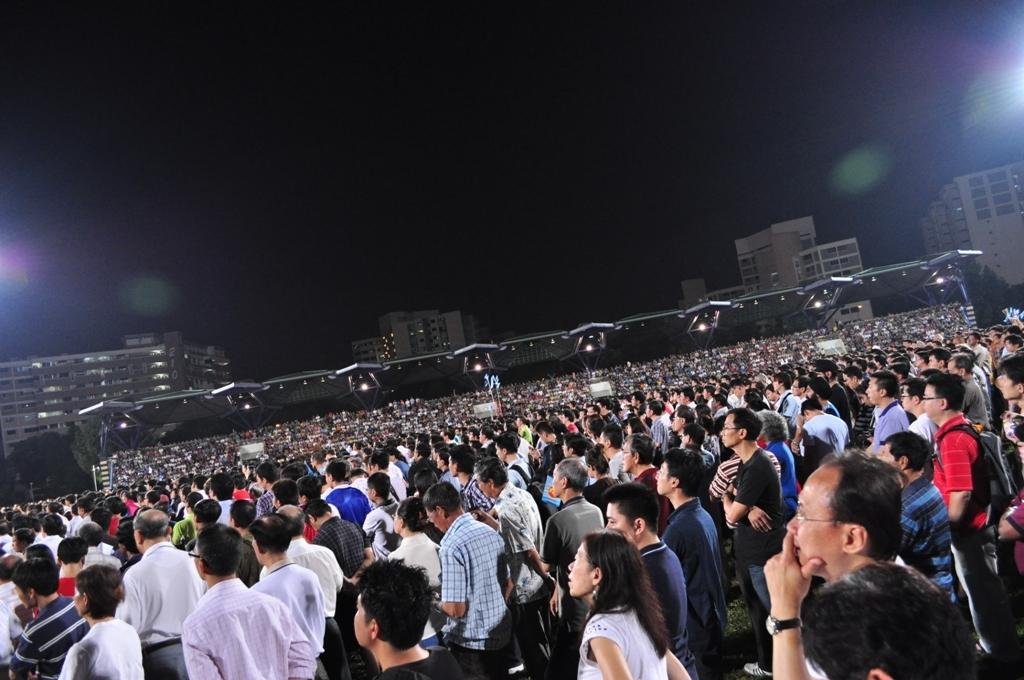What is happening in the image? There are many people standing on the ground. What structures can be seen in the image? There are buildings in the middle of the image. How would you describe the lighting in the image? The background of the image appears to be dark. Where is the dock located in the image? There is no dock present in the image. What type of beast can be seen roaming around in the image? There are no beasts present in the image. 